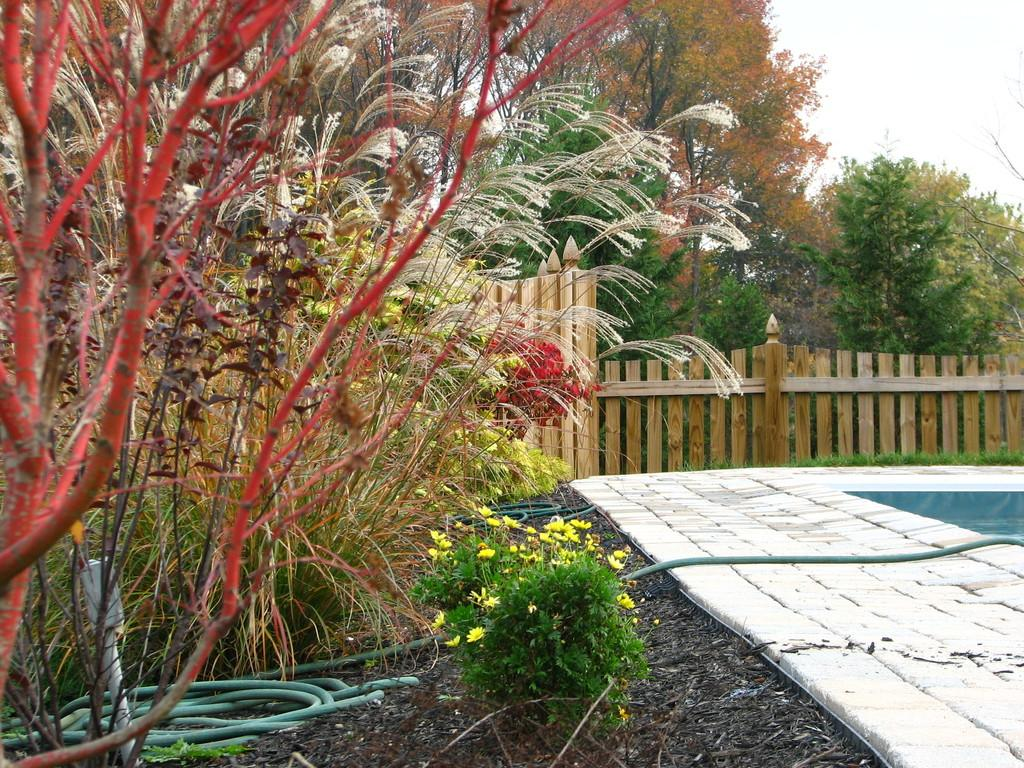What type of vegetation can be seen in the image? There are many plants and trees in the image. What kind of fencing is present in the image? There is wooden fencing in the image. Where is the walkway located in the image? The walkway is on the right side of the image. What other object can be seen in the image? There is a pipe in the image. Are there any flowers visible in the image? Yes, there are flowers in the image. What type of behavior is exhibited by the hospital in the image? There is no hospital present in the image, so it is not possible to discuss its behavior. 